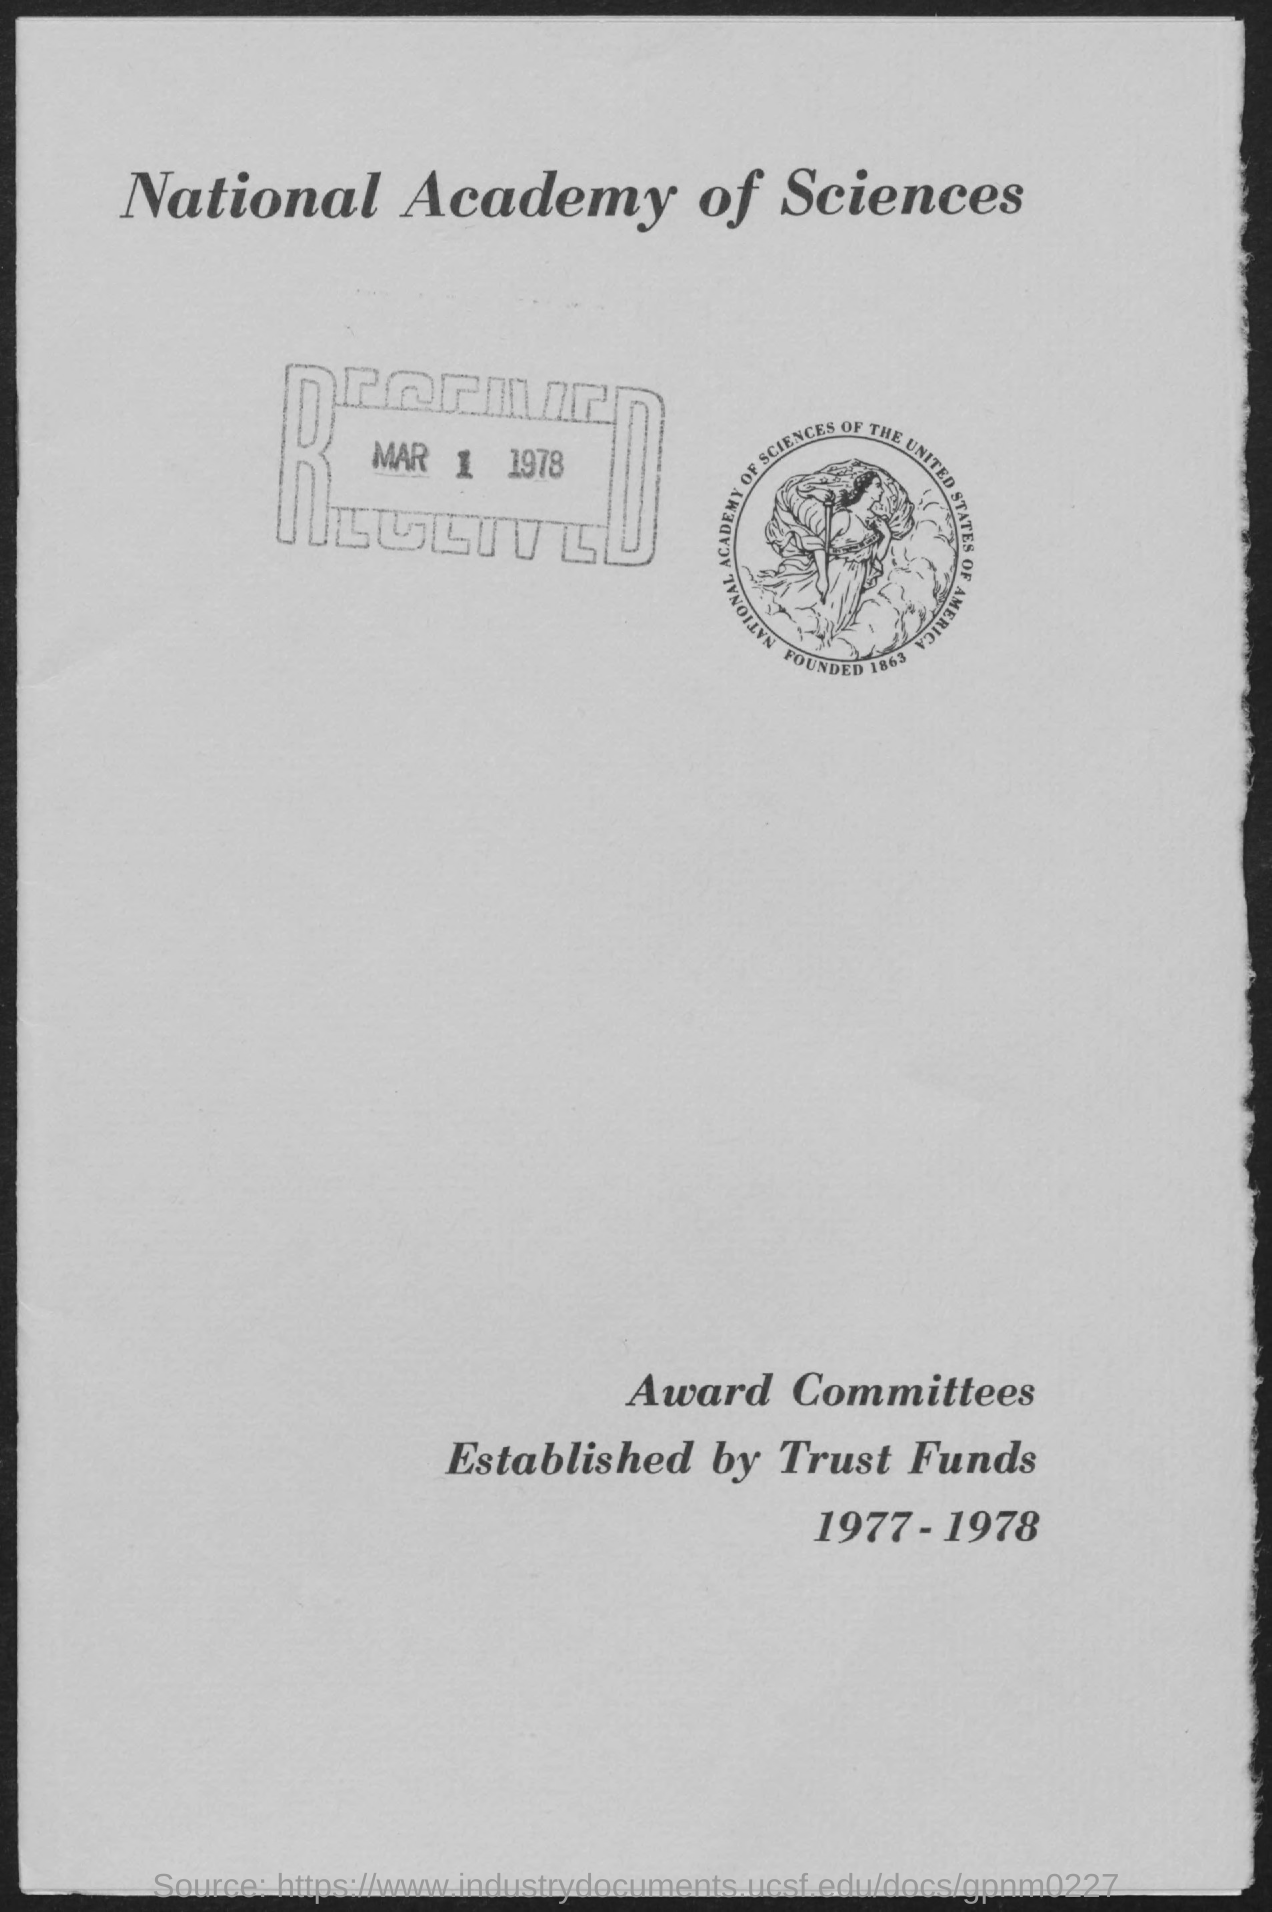Who established award committees?
Give a very brief answer. Trust funds. What is the Title of the document?
Your answer should be compact. National academy of sciences. When was it received?
Make the answer very short. Mar 1 1978. 